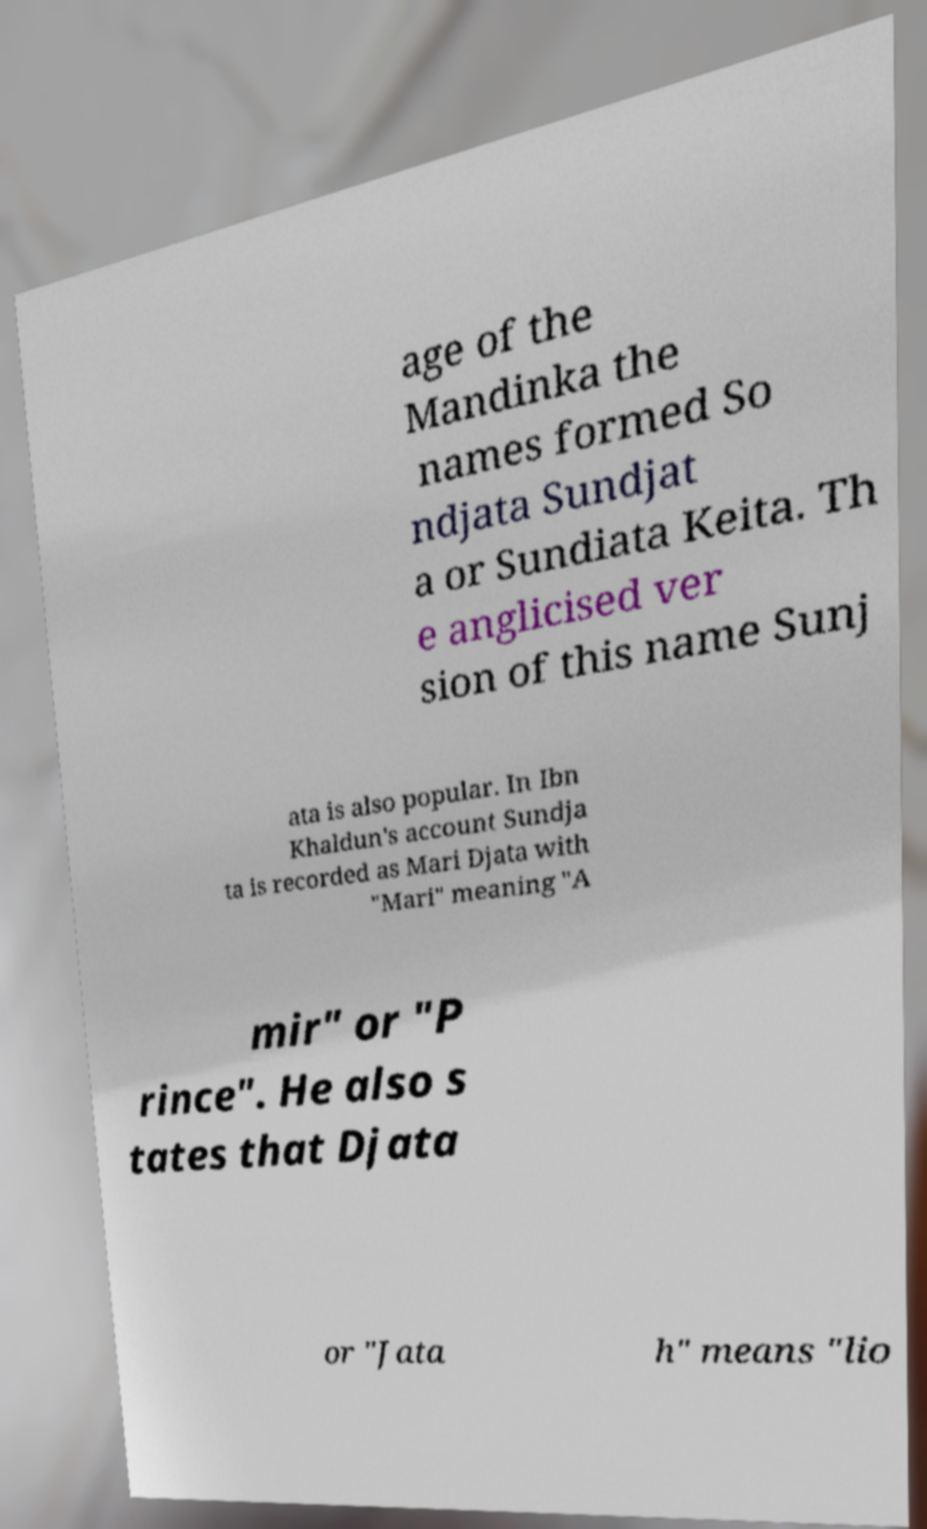There's text embedded in this image that I need extracted. Can you transcribe it verbatim? age of the Mandinka the names formed So ndjata Sundjat a or Sundiata Keita. Th e anglicised ver sion of this name Sunj ata is also popular. In Ibn Khaldun's account Sundja ta is recorded as Mari Djata with "Mari" meaning "A mir" or "P rince". He also s tates that Djata or "Jata h" means "lio 